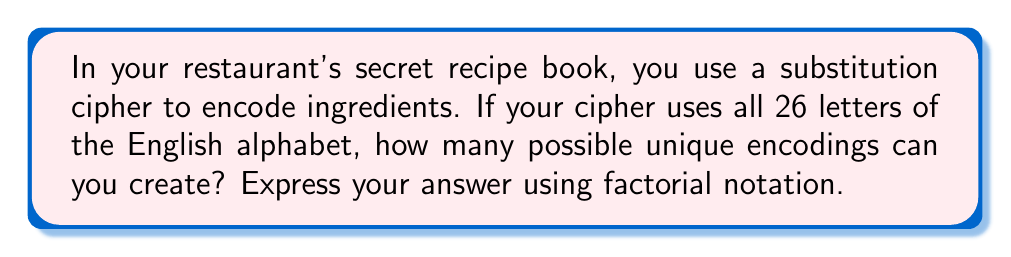Provide a solution to this math problem. Let's approach this step-by-step:

1) In a substitution cipher, each letter of the plaintext alphabet is replaced by a different letter of the cipher alphabet.

2) For the first letter of the plaintext alphabet, we have 26 choices in the cipher alphabet.

3) For the second letter, we have 25 choices, as one letter has already been used.

4) For the third letter, we have 24 choices, and so on.

5) This continues until we reach the last letter, for which we have only 1 choice left.

6) Mathematically, this can be represented as:

   $$26 \times 25 \times 24 \times ... \times 2 \times 1$$

7) This is the definition of 26 factorial, written as 26!

Therefore, the number of possible permutations for a substitution cipher using a 26-letter alphabet is 26!.
Answer: 26! 